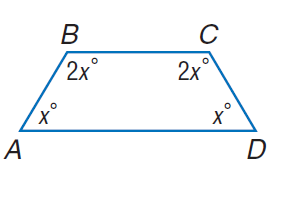Answer the mathemtical geometry problem and directly provide the correct option letter.
Question: Find m \angle D.
Choices: A: 30 B: 60 C: 90 D: 120 B 